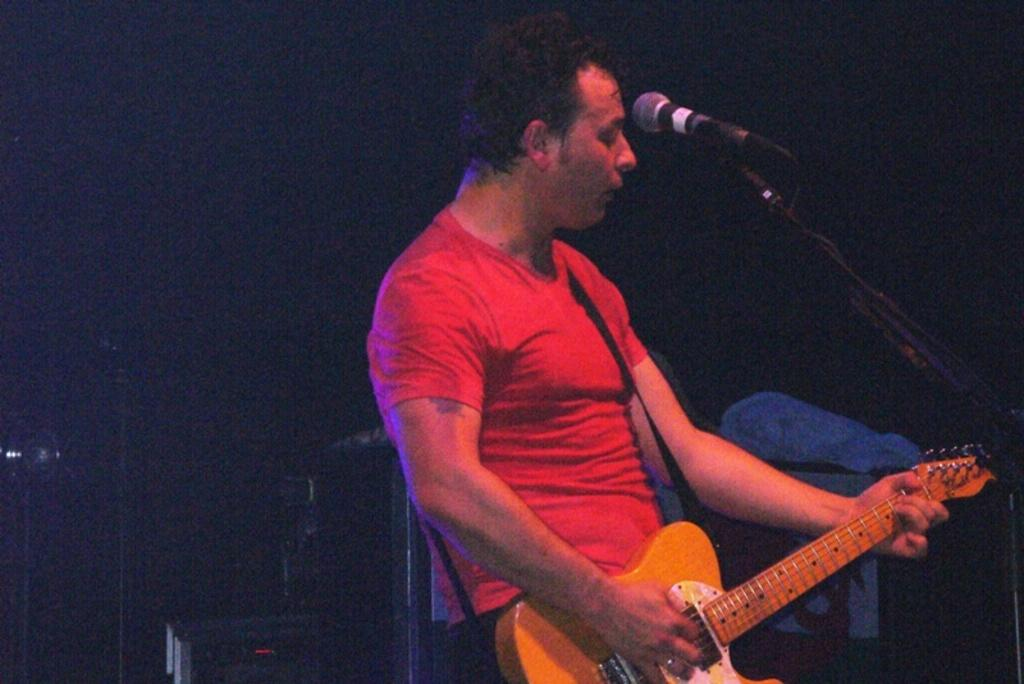What is the color of the background in the image? The background of the image is dark. Can you describe the person in the image? There is a man in the image, and he is wearing a red shirt. What is the man doing in the image? The man is standing in front of a microphone and playing a guitar. What type of chess pieces can be seen on the table in the image? There is no table or chess pieces present in the image. What title is the man holding in the image? The man is not holding any title in the image; he is playing a guitar and standing in front of a microphone. 